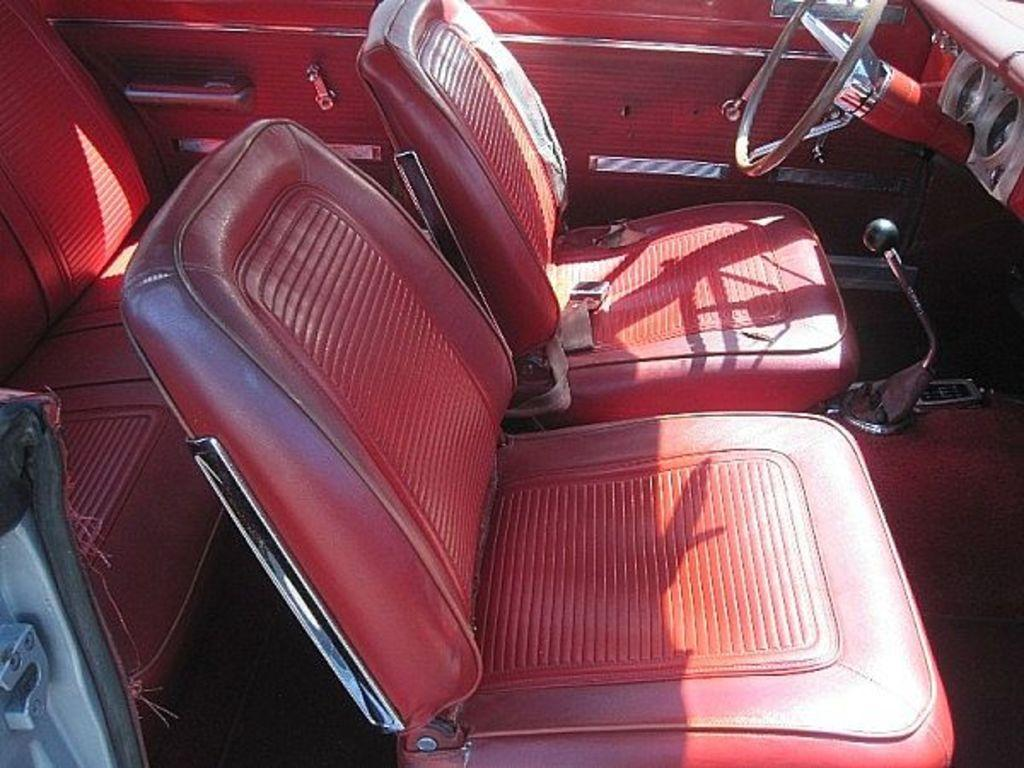What type of space is depicted in the image? The image shows the inside view of a vehicle. What can be found inside the vehicle? There are seats, a steering wheel, and a gear lever in the vehicle. How does one enter or exit the vehicle? There are doors in the vehicle for entering and exiting. Can you see a goldfish swimming in the shade inside the vehicle? There is no goldfish or shade present inside the vehicle in the image. 